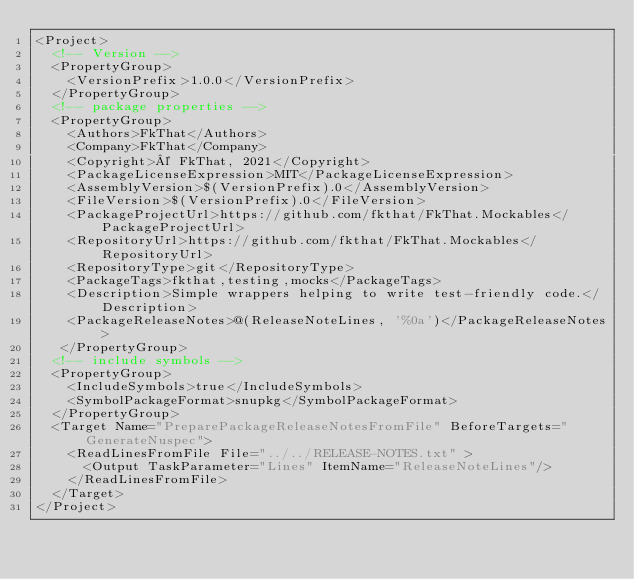<code> <loc_0><loc_0><loc_500><loc_500><_XML_><Project>
  <!-- Version -->
  <PropertyGroup>
    <VersionPrefix>1.0.0</VersionPrefix>
  </PropertyGroup>
  <!-- package properties -->
  <PropertyGroup>
    <Authors>FkThat</Authors>
    <Company>FkThat</Company>
    <Copyright>© FkThat, 2021</Copyright>
    <PackageLicenseExpression>MIT</PackageLicenseExpression>
    <AssemblyVersion>$(VersionPrefix).0</AssemblyVersion>
    <FileVersion>$(VersionPrefix).0</FileVersion>
    <PackageProjectUrl>https://github.com/fkthat/FkThat.Mockables</PackageProjectUrl>
    <RepositoryUrl>https://github.com/fkthat/FkThat.Mockables</RepositoryUrl>
    <RepositoryType>git</RepositoryType>
    <PackageTags>fkthat,testing,mocks</PackageTags>
    <Description>Simple wrappers helping to write test-friendly code.</Description>
    <PackageReleaseNotes>@(ReleaseNoteLines, '%0a')</PackageReleaseNotes>
   </PropertyGroup>
  <!-- include symbols -->
  <PropertyGroup>
    <IncludeSymbols>true</IncludeSymbols>
    <SymbolPackageFormat>snupkg</SymbolPackageFormat>
  </PropertyGroup>
  <Target Name="PreparePackageReleaseNotesFromFile" BeforeTargets="GenerateNuspec">
    <ReadLinesFromFile File="../../RELEASE-NOTES.txt" >
      <Output TaskParameter="Lines" ItemName="ReleaseNoteLines"/>
    </ReadLinesFromFile>
  </Target>
</Project>
</code> 